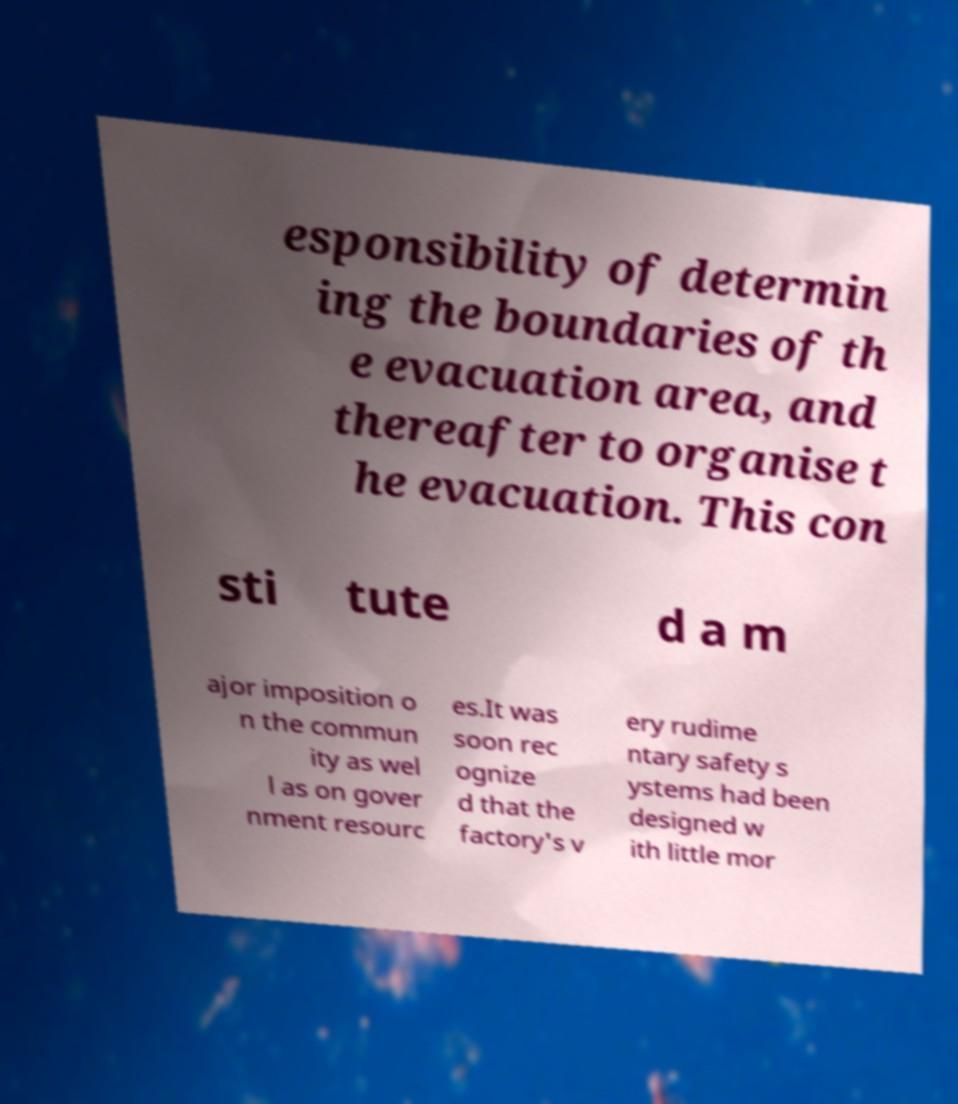For documentation purposes, I need the text within this image transcribed. Could you provide that? esponsibility of determin ing the boundaries of th e evacuation area, and thereafter to organise t he evacuation. This con sti tute d a m ajor imposition o n the commun ity as wel l as on gover nment resourc es.It was soon rec ognize d that the factory's v ery rudime ntary safety s ystems had been designed w ith little mor 